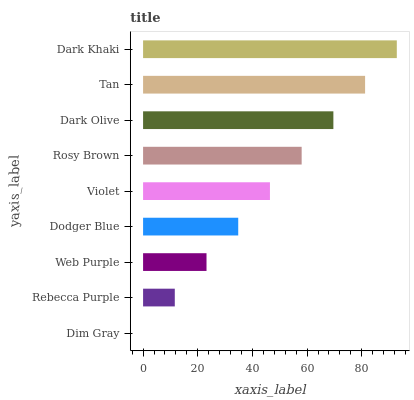Is Dim Gray the minimum?
Answer yes or no. Yes. Is Dark Khaki the maximum?
Answer yes or no. Yes. Is Rebecca Purple the minimum?
Answer yes or no. No. Is Rebecca Purple the maximum?
Answer yes or no. No. Is Rebecca Purple greater than Dim Gray?
Answer yes or no. Yes. Is Dim Gray less than Rebecca Purple?
Answer yes or no. Yes. Is Dim Gray greater than Rebecca Purple?
Answer yes or no. No. Is Rebecca Purple less than Dim Gray?
Answer yes or no. No. Is Violet the high median?
Answer yes or no. Yes. Is Violet the low median?
Answer yes or no. Yes. Is Dodger Blue the high median?
Answer yes or no. No. Is Web Purple the low median?
Answer yes or no. No. 